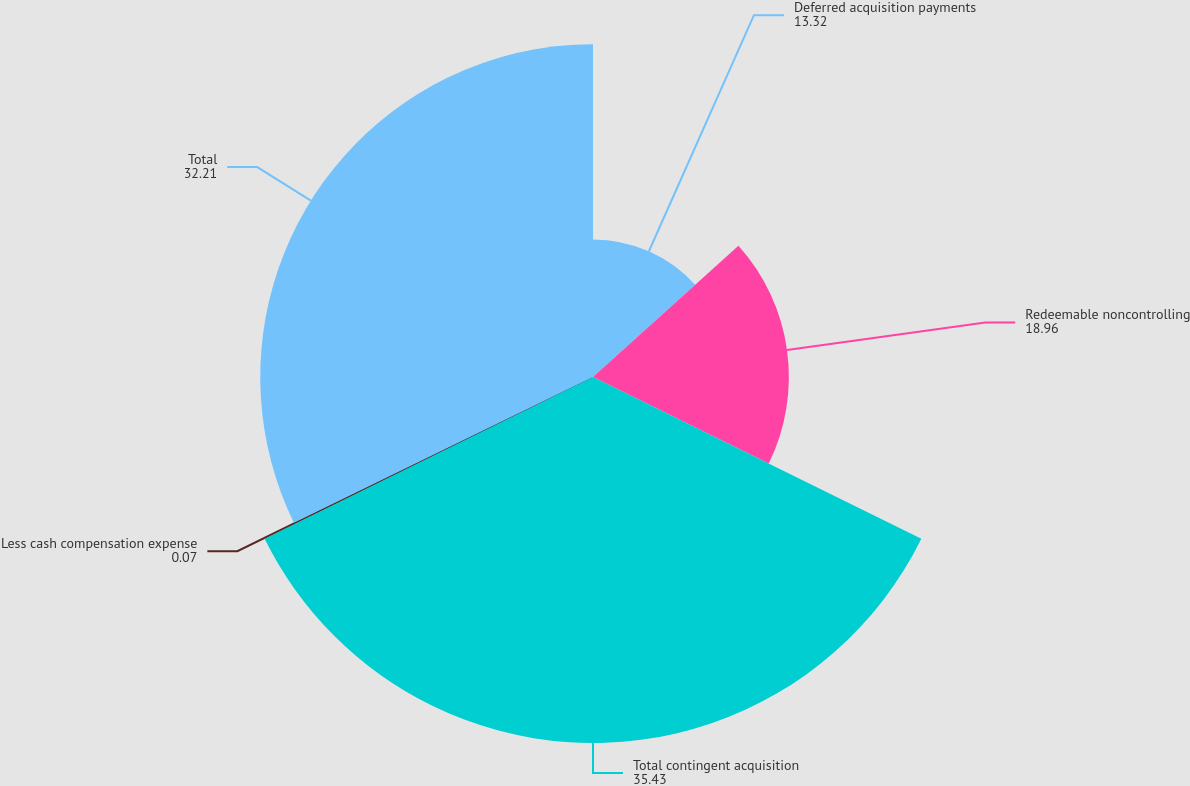Convert chart. <chart><loc_0><loc_0><loc_500><loc_500><pie_chart><fcel>Deferred acquisition payments<fcel>Redeemable noncontrolling<fcel>Total contingent acquisition<fcel>Less cash compensation expense<fcel>Total<nl><fcel>13.32%<fcel>18.96%<fcel>35.43%<fcel>0.07%<fcel>32.21%<nl></chart> 